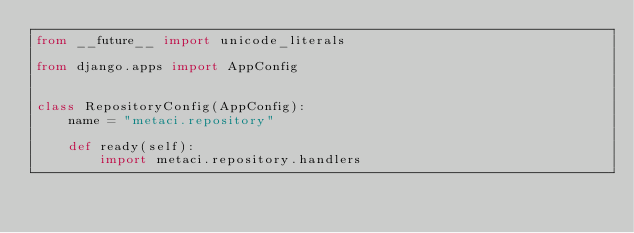Convert code to text. <code><loc_0><loc_0><loc_500><loc_500><_Python_>from __future__ import unicode_literals

from django.apps import AppConfig


class RepositoryConfig(AppConfig):
    name = "metaci.repository"

    def ready(self):
        import metaci.repository.handlers
</code> 